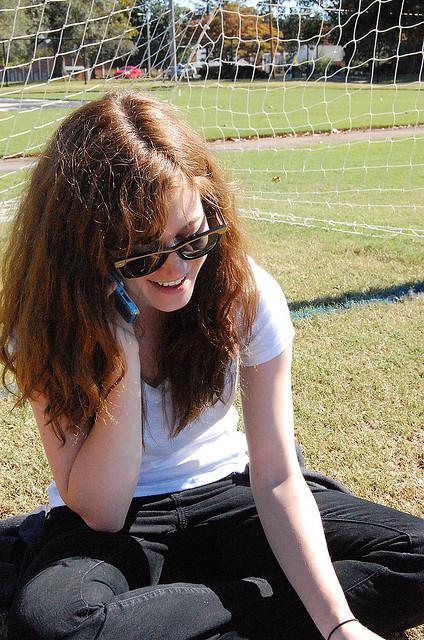Is the woman talking on her cell phone?
Write a very short answer. Yes. What color is the cell phone case?
Keep it brief. Blue. What is behind the woman?
Keep it brief. Net. 